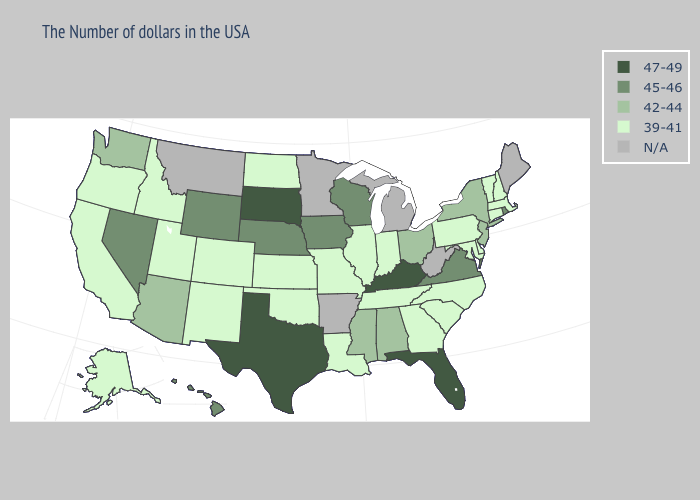What is the value of Georgia?
Answer briefly. 39-41. What is the highest value in the USA?
Write a very short answer. 47-49. Does Delaware have the lowest value in the USA?
Short answer required. Yes. Name the states that have a value in the range 42-44?
Write a very short answer. New York, New Jersey, Ohio, Alabama, Mississippi, Arizona, Washington. Which states have the lowest value in the USA?
Be succinct. Massachusetts, New Hampshire, Vermont, Connecticut, Delaware, Maryland, Pennsylvania, North Carolina, South Carolina, Georgia, Indiana, Tennessee, Illinois, Louisiana, Missouri, Kansas, Oklahoma, North Dakota, Colorado, New Mexico, Utah, Idaho, California, Oregon, Alaska. Name the states that have a value in the range N/A?
Keep it brief. Maine, West Virginia, Michigan, Arkansas, Minnesota, Montana. What is the value of Maine?
Concise answer only. N/A. Does Nebraska have the lowest value in the MidWest?
Quick response, please. No. What is the lowest value in states that border Iowa?
Be succinct. 39-41. Name the states that have a value in the range 45-46?
Give a very brief answer. Rhode Island, Virginia, Wisconsin, Iowa, Nebraska, Wyoming, Nevada, Hawaii. Among the states that border Missouri , which have the highest value?
Answer briefly. Kentucky. Name the states that have a value in the range 39-41?
Give a very brief answer. Massachusetts, New Hampshire, Vermont, Connecticut, Delaware, Maryland, Pennsylvania, North Carolina, South Carolina, Georgia, Indiana, Tennessee, Illinois, Louisiana, Missouri, Kansas, Oklahoma, North Dakota, Colorado, New Mexico, Utah, Idaho, California, Oregon, Alaska. Among the states that border North Dakota , which have the lowest value?
Be succinct. South Dakota. 